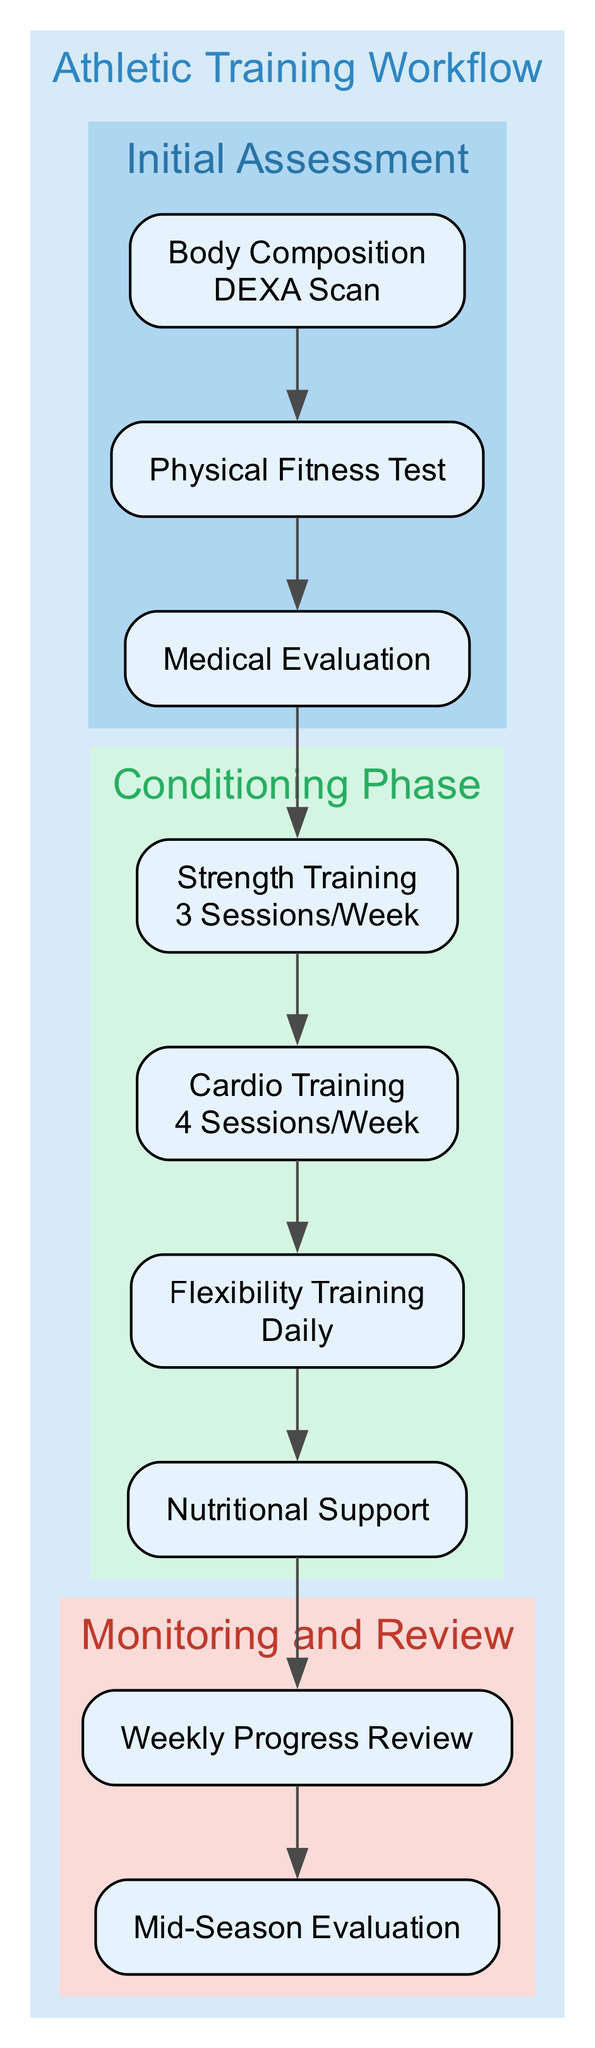What is the first assessment in the workflow? The diagram indicates that the first assessment is the "Body Composition" analysis, which is followed by the DEXA Scan. This is identified as the first node in the "Initial Assessment" cluster.
Answer: Body Composition Analysis How many sessions per week are designated for Strength Training? The diagram clearly states that Strength Training is scheduled for "3 Sessions per Week," as seen in the "Conditioning Phase" section.
Answer: 3 Sessions per Week What type of testing is included in the Physical Fitness Test? The Physical Fitness Test node specifies three tests: Cardiovascular Endurance, Muscular Strength, and Flexibility. To answer specifically, I can refer to the "Physical Fitness Test" node, which describes these tests.
Answer: VO2 Max Test, 1RM Bench Press, Sit and Reach Test Which phase follows the Medical Evaluation in the diagram? The diagram flows from the "Medical Evaluation" node to the "Strength Training" node, indicating that the next phase in the workflow is the Conditioning Phase after this evaluation.
Answer: Conditioning Phase What element of Nutritional Support is mentioned in the diagram? The diagram specifies that the Nutritional Support consists of a tailored diet plan and supplementation including Protein Shakes and Vitamins, which can be found under the "Nutritional Support" node.
Answer: Tailored Diet Plan and Supplementation What is assessed in the Weekly Progress Review? The Weekly Progress Review node lists "Strength Gains," "Endurance Improvement," and "Flexibility Enhancement" as the performance metrics assessed, which are essential components of the progress review process.
Answer: Strength Gains, Endurance Improvement, Flexibility Enhancement What occurs in the Mid-Season Evaluation? The diagram indicates that the Mid-Season Evaluation includes "Reassessment Tests" like VO2 Max Retest and 1RM Retest, and adjustments to the training regimen based on the performance metrics, which reflect how this evaluation is structured.
Answer: Reassessment Tests and Adjusting Training Regimen How often is Flexibility Training scheduled? According to the diagram, Flexibility Training is scheduled "Daily," indicating a commitment to regular training in this area, as explicitly stated in the "Conditioning Phase."
Answer: Daily What is the connection between Body Composition Analysis and Physical Fitness Test? The illustration shows that the "Body Composition Analysis" directly leads to the "Physical Fitness Test," which means that the analysis step is foundational before undertaking physical testing in this workflow.
Answer: Direct Connection 